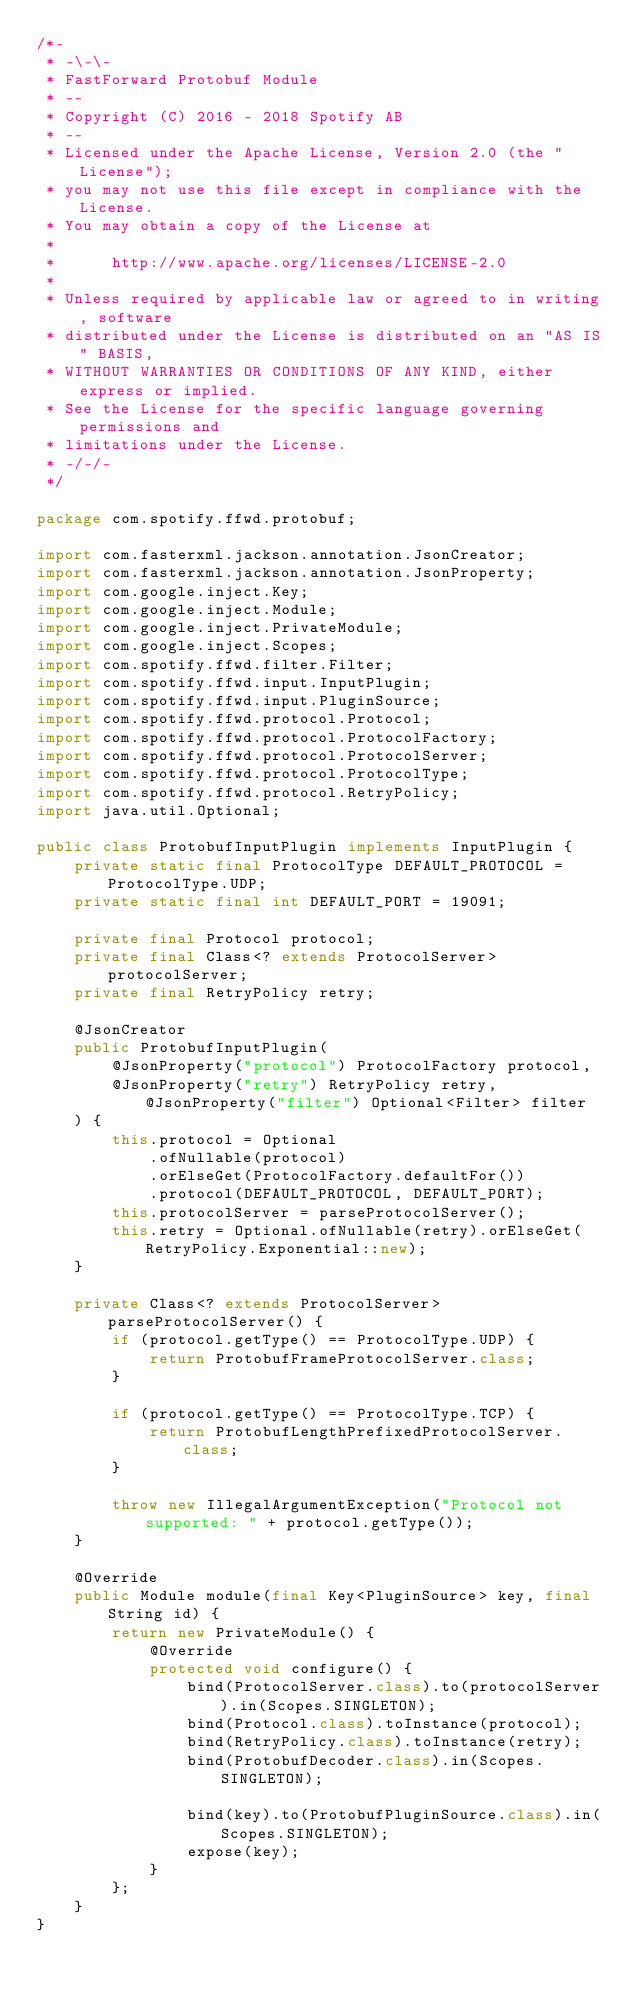<code> <loc_0><loc_0><loc_500><loc_500><_Java_>/*-
 * -\-\-
 * FastForward Protobuf Module
 * --
 * Copyright (C) 2016 - 2018 Spotify AB
 * --
 * Licensed under the Apache License, Version 2.0 (the "License");
 * you may not use this file except in compliance with the License.
 * You may obtain a copy of the License at
 * 
 *      http://www.apache.org/licenses/LICENSE-2.0
 * 
 * Unless required by applicable law or agreed to in writing, software
 * distributed under the License is distributed on an "AS IS" BASIS,
 * WITHOUT WARRANTIES OR CONDITIONS OF ANY KIND, either express or implied.
 * See the License for the specific language governing permissions and
 * limitations under the License.
 * -/-/-
 */

package com.spotify.ffwd.protobuf;

import com.fasterxml.jackson.annotation.JsonCreator;
import com.fasterxml.jackson.annotation.JsonProperty;
import com.google.inject.Key;
import com.google.inject.Module;
import com.google.inject.PrivateModule;
import com.google.inject.Scopes;
import com.spotify.ffwd.filter.Filter;
import com.spotify.ffwd.input.InputPlugin;
import com.spotify.ffwd.input.PluginSource;
import com.spotify.ffwd.protocol.Protocol;
import com.spotify.ffwd.protocol.ProtocolFactory;
import com.spotify.ffwd.protocol.ProtocolServer;
import com.spotify.ffwd.protocol.ProtocolType;
import com.spotify.ffwd.protocol.RetryPolicy;
import java.util.Optional;

public class ProtobufInputPlugin implements InputPlugin {
    private static final ProtocolType DEFAULT_PROTOCOL = ProtocolType.UDP;
    private static final int DEFAULT_PORT = 19091;

    private final Protocol protocol;
    private final Class<? extends ProtocolServer> protocolServer;
    private final RetryPolicy retry;

    @JsonCreator
    public ProtobufInputPlugin(
        @JsonProperty("protocol") ProtocolFactory protocol,
        @JsonProperty("retry") RetryPolicy retry, @JsonProperty("filter") Optional<Filter> filter
    ) {
        this.protocol = Optional
            .ofNullable(protocol)
            .orElseGet(ProtocolFactory.defaultFor())
            .protocol(DEFAULT_PROTOCOL, DEFAULT_PORT);
        this.protocolServer = parseProtocolServer();
        this.retry = Optional.ofNullable(retry).orElseGet(RetryPolicy.Exponential::new);
    }

    private Class<? extends ProtocolServer> parseProtocolServer() {
        if (protocol.getType() == ProtocolType.UDP) {
            return ProtobufFrameProtocolServer.class;
        }

        if (protocol.getType() == ProtocolType.TCP) {
            return ProtobufLengthPrefixedProtocolServer.class;
        }

        throw new IllegalArgumentException("Protocol not supported: " + protocol.getType());
    }

    @Override
    public Module module(final Key<PluginSource> key, final String id) {
        return new PrivateModule() {
            @Override
            protected void configure() {
                bind(ProtocolServer.class).to(protocolServer).in(Scopes.SINGLETON);
                bind(Protocol.class).toInstance(protocol);
                bind(RetryPolicy.class).toInstance(retry);
                bind(ProtobufDecoder.class).in(Scopes.SINGLETON);

                bind(key).to(ProtobufPluginSource.class).in(Scopes.SINGLETON);
                expose(key);
            }
        };
    }
}
</code> 